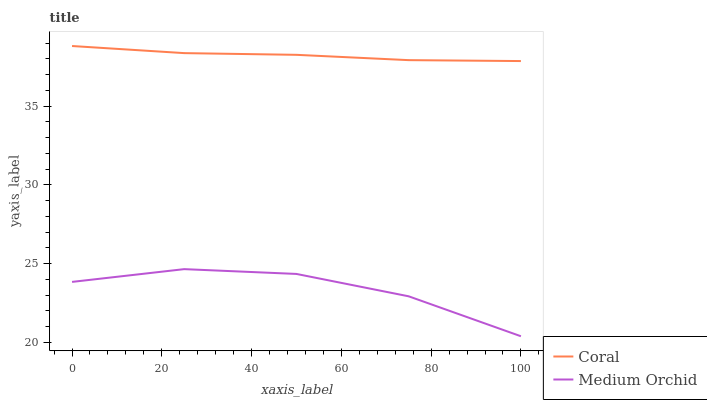Does Medium Orchid have the minimum area under the curve?
Answer yes or no. Yes. Does Coral have the maximum area under the curve?
Answer yes or no. Yes. Does Medium Orchid have the maximum area under the curve?
Answer yes or no. No. Is Coral the smoothest?
Answer yes or no. Yes. Is Medium Orchid the roughest?
Answer yes or no. Yes. Is Medium Orchid the smoothest?
Answer yes or no. No. Does Medium Orchid have the lowest value?
Answer yes or no. Yes. Does Coral have the highest value?
Answer yes or no. Yes. Does Medium Orchid have the highest value?
Answer yes or no. No. Is Medium Orchid less than Coral?
Answer yes or no. Yes. Is Coral greater than Medium Orchid?
Answer yes or no. Yes. Does Medium Orchid intersect Coral?
Answer yes or no. No. 